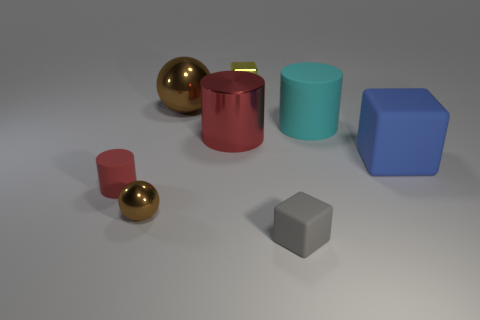Are there fewer small brown things than small green shiny cylinders?
Provide a short and direct response. No. What shape is the red object to the right of the large brown ball behind the big red shiny cylinder that is in front of the small yellow metallic cube?
Provide a succinct answer. Cylinder. How many objects are either tiny rubber objects that are in front of the red rubber cylinder or big matte things that are behind the tiny gray cube?
Make the answer very short. 3. There is a gray matte object; are there any big metallic spheres in front of it?
Offer a terse response. No. What number of objects are blocks behind the red shiny thing or tiny cubes?
Your answer should be compact. 2. How many yellow objects are either rubber objects or small cylinders?
Your response must be concise. 0. How many other objects are the same color as the large ball?
Provide a short and direct response. 1. Is the number of big brown shiny things in front of the large brown object less than the number of big metallic objects?
Provide a short and direct response. Yes. There is a large rubber thing right of the big cylinder to the right of the tiny shiny thing behind the small red matte cylinder; what color is it?
Offer a terse response. Blue. There is another metallic thing that is the same shape as the tiny brown object; what is its size?
Make the answer very short. Large. 